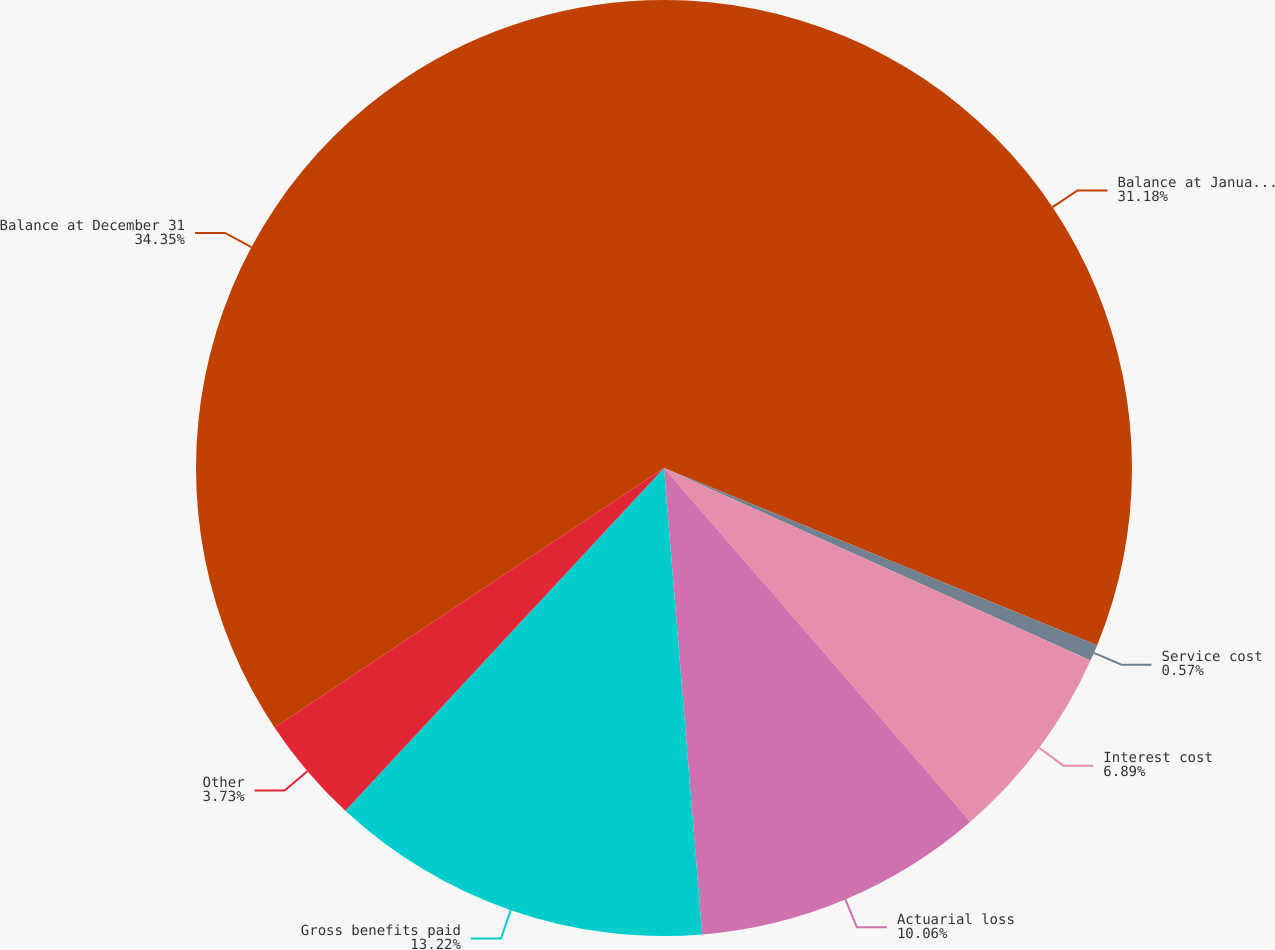Convert chart. <chart><loc_0><loc_0><loc_500><loc_500><pie_chart><fcel>Balance at January 1<fcel>Service cost<fcel>Interest cost<fcel>Actuarial loss<fcel>Gross benefits paid<fcel>Other<fcel>Balance at December 31<nl><fcel>31.18%<fcel>0.57%<fcel>6.89%<fcel>10.06%<fcel>13.22%<fcel>3.73%<fcel>34.35%<nl></chart> 